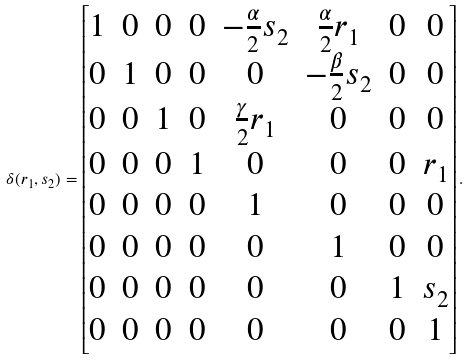Convert formula to latex. <formula><loc_0><loc_0><loc_500><loc_500>\delta ( r _ { 1 } , s _ { 2 } ) = \begin{bmatrix} 1 & 0 & 0 & 0 & - \frac { \alpha } { 2 } s _ { 2 } & \frac { \alpha } { 2 } r _ { 1 } & 0 & 0 \\ 0 & 1 & 0 & 0 & 0 & - \frac { \beta } { 2 } s _ { 2 } & 0 & 0 \\ 0 & 0 & 1 & 0 & \frac { \gamma } { 2 } r _ { 1 } & 0 & 0 & 0 \\ 0 & 0 & 0 & 1 & 0 & 0 & 0 & r _ { 1 } \\ 0 & 0 & 0 & 0 & 1 & 0 & 0 & 0 \\ 0 & 0 & 0 & 0 & 0 & 1 & 0 & 0 \\ 0 & 0 & 0 & 0 & 0 & 0 & 1 & s _ { 2 } \\ 0 & 0 & 0 & 0 & 0 & 0 & 0 & 1 \end{bmatrix} .</formula> 